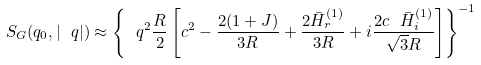Convert formula to latex. <formula><loc_0><loc_0><loc_500><loc_500>S _ { G } ( q _ { 0 } , | \ q | ) \approx \left \{ \ q ^ { 2 } \frac { R } { 2 } \left [ c ^ { 2 } - \frac { 2 ( 1 + J ) } { 3 R } + \frac { 2 \bar { H } _ { r } ^ { ( 1 ) } } { 3 R } + i \frac { 2 c \ \bar { H } _ { i } ^ { ( 1 ) } } { \sqrt { 3 } R } \right ] \right \} ^ { - 1 }</formula> 